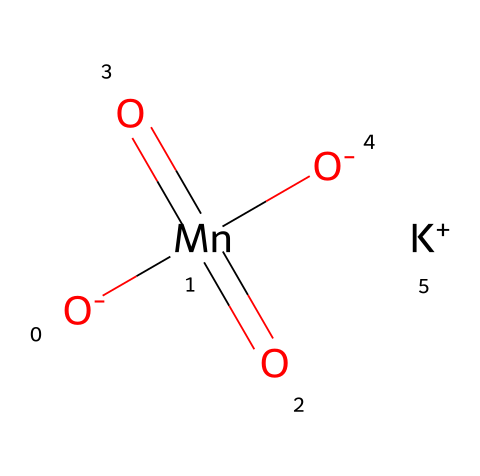What is the central atom in this structure? The structure shows manganese (Mn) at the center, surrounded by oxygen atoms and a potassium ion, indicating it serves as the central atom in the molecule.
Answer: manganese How many oxygen atoms are present? The SMILES representation indicates four oxygen atoms: one bonded to potassium, three double-bonded to manganese, and one oxygen with a single bond to manganese.
Answer: four What is the oxidation state of manganese in this compound? In the structure, manganese typically has an oxidation state of +7 in potassium permanganate, as it is bonded to four oxygen atoms where three contribute a -2 charge and one a -1, balancing to +7.
Answer: +7 What functional group is characteristic of oxidizers found in this structure? The presence of multiple double-bonded oxygen atoms to manganese signifies that this compound acts as an oxidizer, often seen in compounds like permanganates.
Answer: permanganate Is potassium permanganate soluble in water? Potassium permanganate is known for its high solubility in water, which is a common property for many ionic compounds involving alkali metals.
Answer: yes What role does potassium play in this compound? Potassium acts as a counterion to the permanganate ion, balancing the overall charge of the compound and facilitating its ionic character.
Answer: counterion 